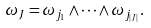<formula> <loc_0><loc_0><loc_500><loc_500>\omega _ { J } = \omega _ { j _ { 1 } } \wedge \cdots \wedge \omega _ { j _ { | J | } } .</formula> 